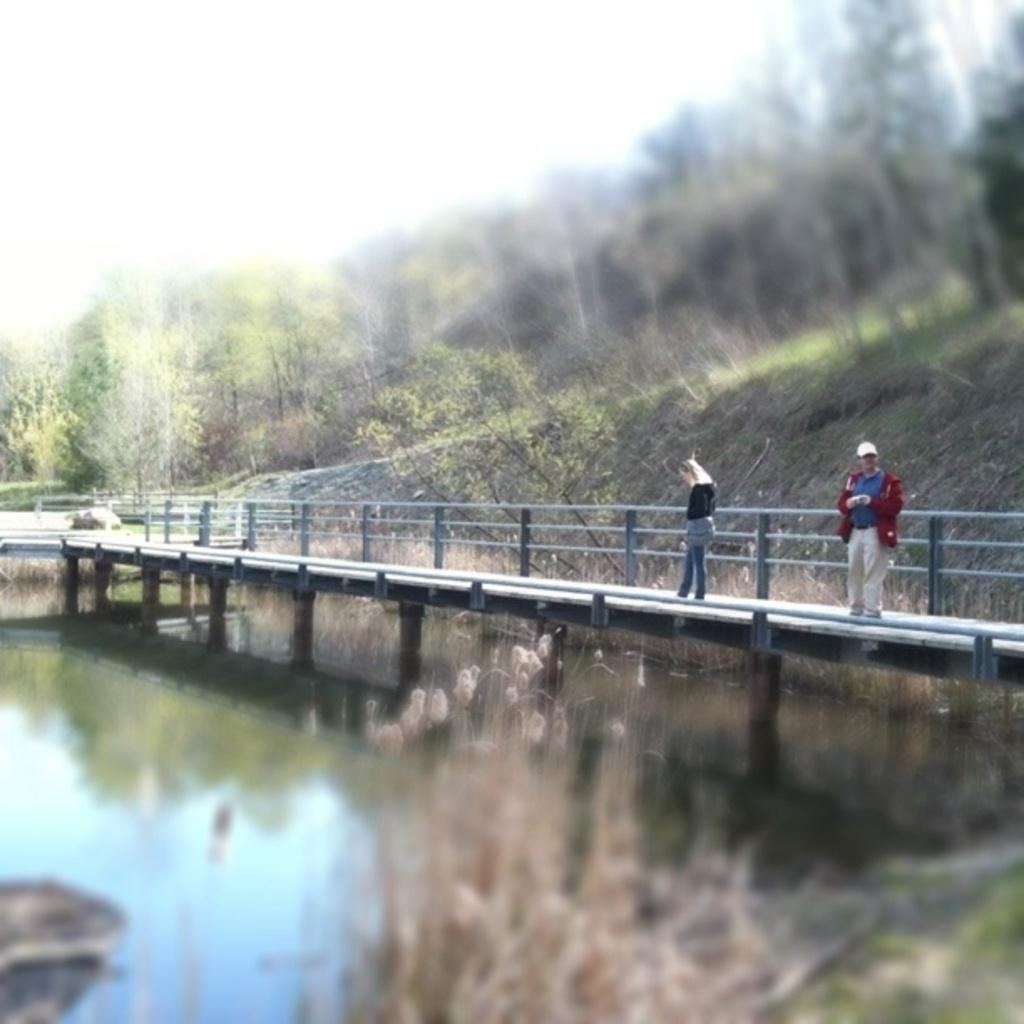What is the main element present in the image? There is water in the image. What else can be seen in the image besides the water? There are plants, two persons standing on a bridge, and the background of the image. Can you describe the bridge in the image? The bridge has railing. What is visible in the background of the image? The background of the image is blurred, but trees and the sky are visible. How many mice are sitting on the table in the image? There is no table or mice present in the image. What type of nut is being cracked by the persons on the bridge? There is no nut or activity of cracking nuts in the image. 